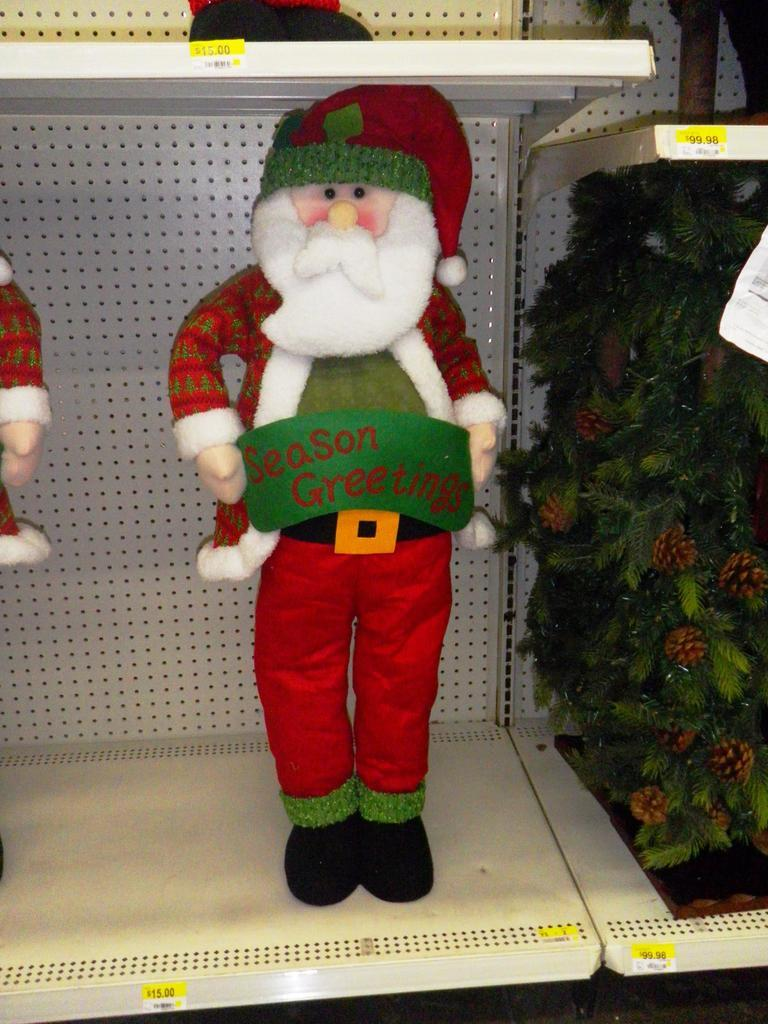<image>
Share a concise interpretation of the image provided. a santa claus in a store holding a banner that says 'season greetings' 